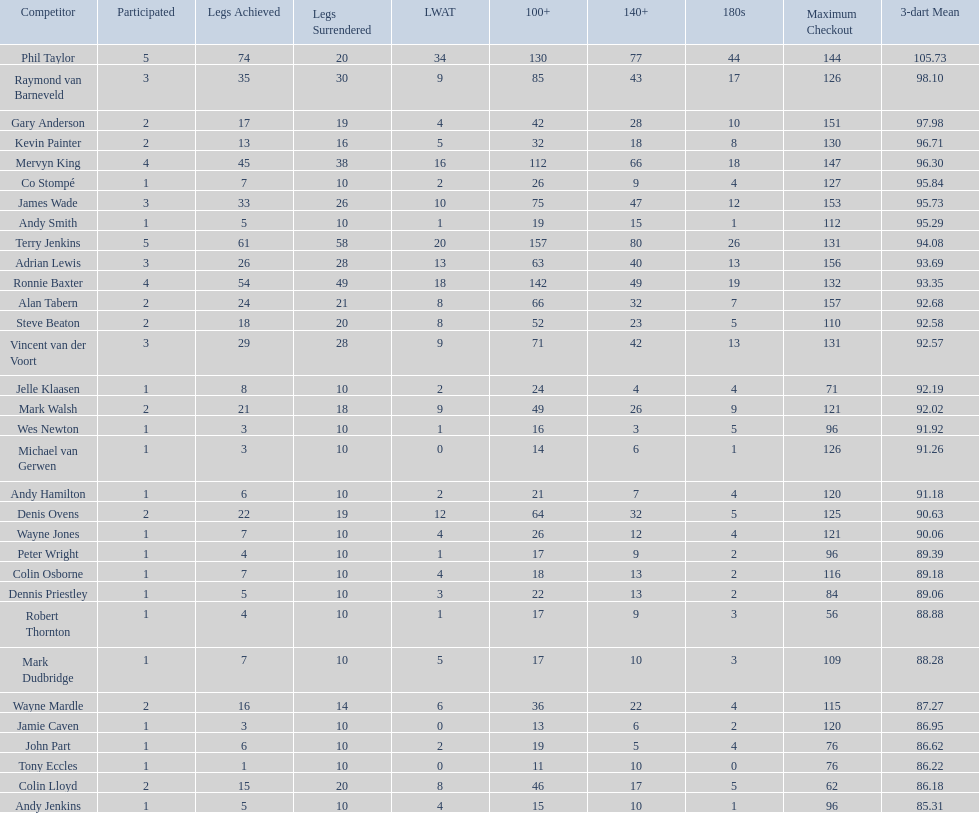What is the total amount of players who played more than 3 games? 4. 